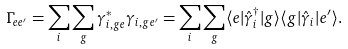Convert formula to latex. <formula><loc_0><loc_0><loc_500><loc_500>\Gamma _ { e e ^ { \prime } } = \sum _ { i } \sum _ { g } \gamma _ { i , g e } ^ { \ast } \gamma _ { i , g e ^ { \prime } } = \sum _ { i } \sum _ { g } \langle e | \hat { \gamma } _ { i } ^ { \dagger } | g \rangle \langle g | \hat { \gamma } _ { i } | e ^ { \prime } \rangle .</formula> 